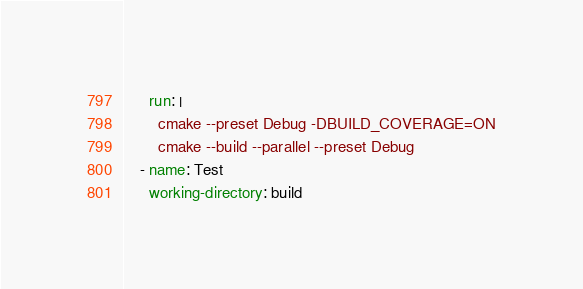Convert code to text. <code><loc_0><loc_0><loc_500><loc_500><_YAML_>      run: |
        cmake --preset Debug -DBUILD_COVERAGE=ON
        cmake --build --parallel --preset Debug
    - name: Test
      working-directory: build</code> 